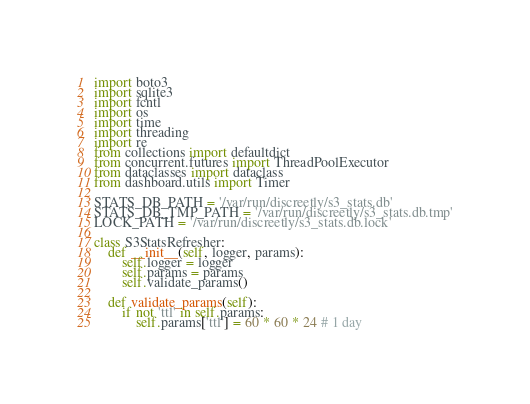Convert code to text. <code><loc_0><loc_0><loc_500><loc_500><_Python_>import boto3
import sqlite3
import fcntl
import os
import time
import threading
import re
from collections import defaultdict
from concurrent.futures import ThreadPoolExecutor
from dataclasses import dataclass
from dashboard.utils import Timer

STATS_DB_PATH = '/var/run/discreetly/s3_stats.db'
STATS_DB_TMP_PATH = '/var/run/discreetly/s3_stats.db.tmp'
LOCK_PATH = '/var/run/discreetly/s3_stats.db.lock'

class S3StatsRefresher:
    def __init__(self, logger, params):
        self.logger = logger
        self.params = params
        self.validate_params()

    def validate_params(self):
        if not 'ttl' in self.params:
            self.params['ttl'] = 60 * 60 * 24 # 1 day</code> 